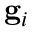Convert formula to latex. <formula><loc_0><loc_0><loc_500><loc_500>g _ { i }</formula> 